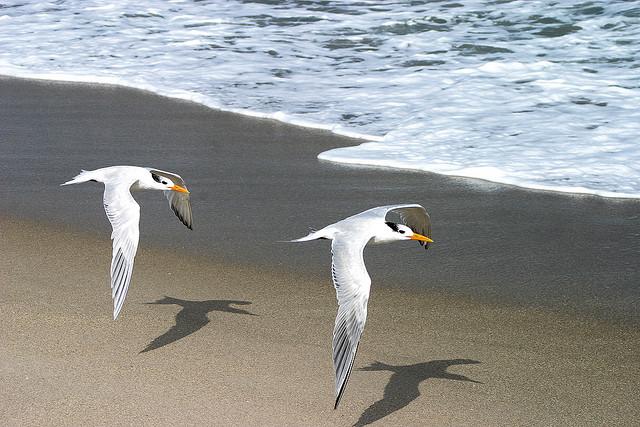What is the shadow on the sand from?
Be succinct. Birds. Are the birds from the same species?
Concise answer only. Yes. What kind of birds are these?
Keep it brief. Seagulls. 